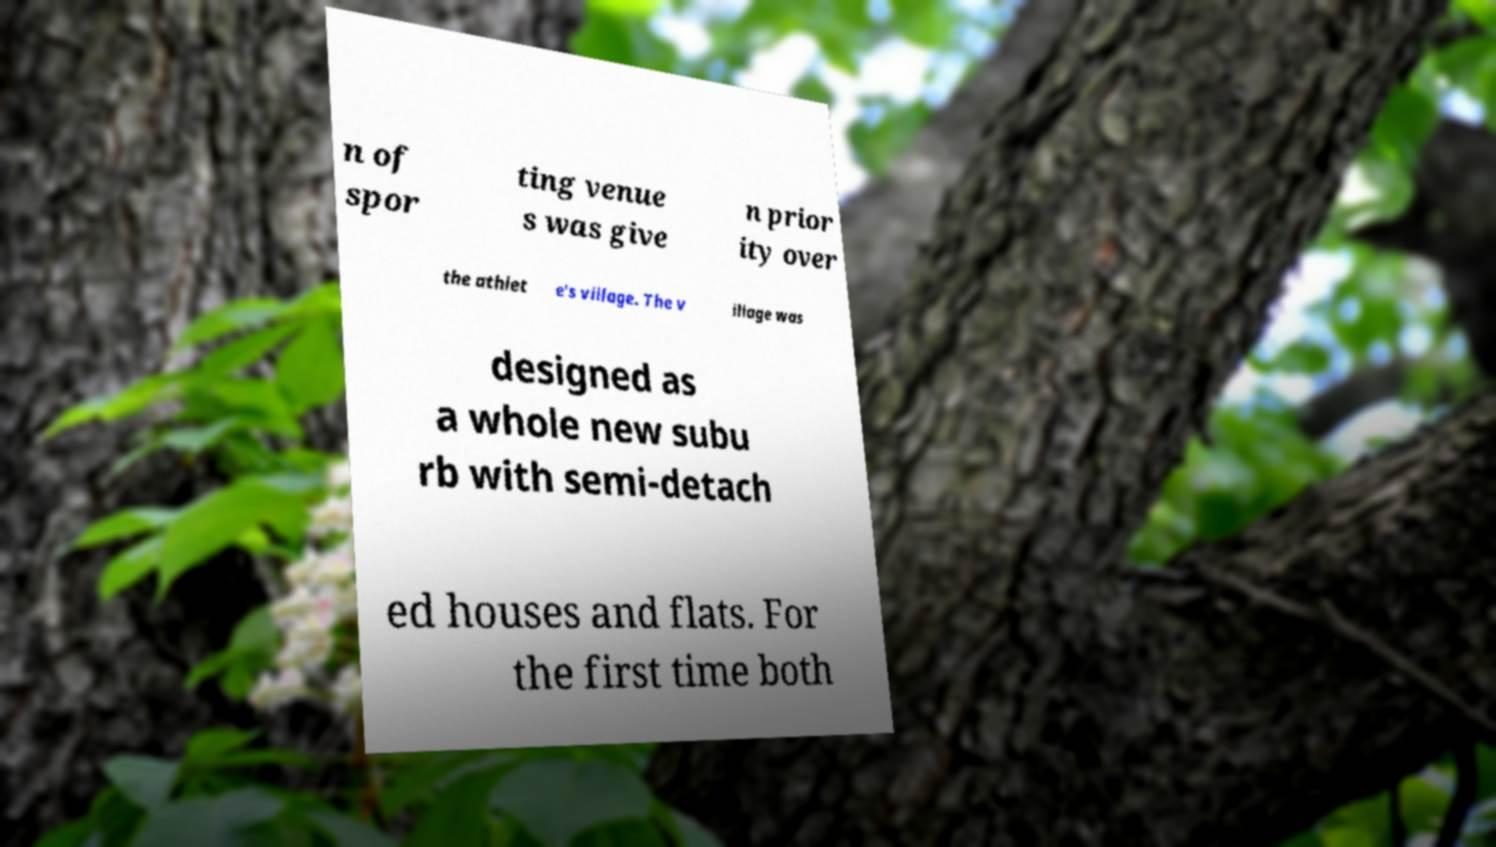Can you accurately transcribe the text from the provided image for me? n of spor ting venue s was give n prior ity over the athlet e's village. The v illage was designed as a whole new subu rb with semi-detach ed houses and flats. For the first time both 